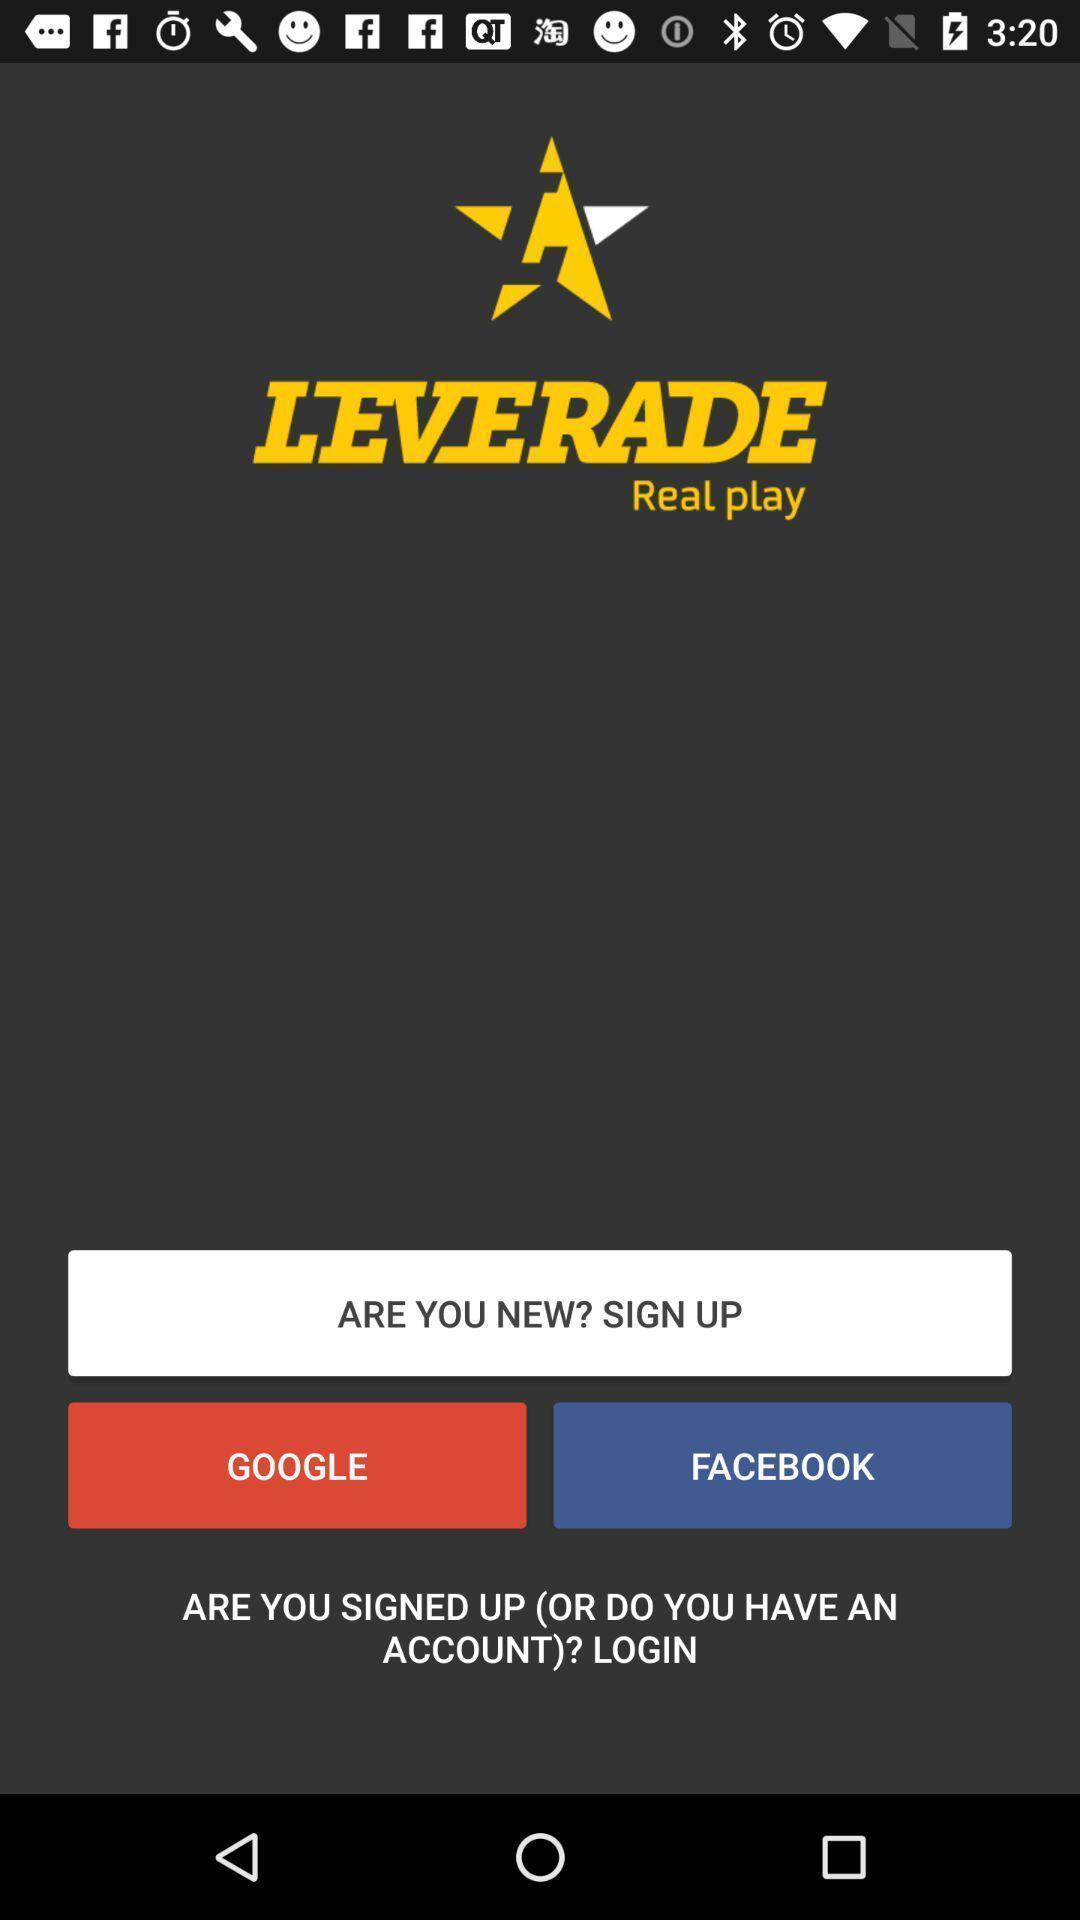Summarize the main components in this picture. Sign up page of an social app. 